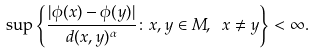Convert formula to latex. <formula><loc_0><loc_0><loc_500><loc_500>\sup \left \{ \frac { | \phi ( x ) - \phi ( y ) | } { d ( x , y ) ^ { \alpha } } \colon x , y \in M , \ x \ne y \right \} < \infty .</formula> 